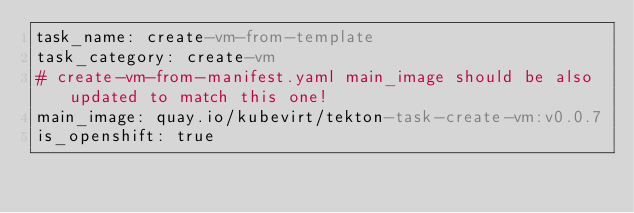Convert code to text. <code><loc_0><loc_0><loc_500><loc_500><_YAML_>task_name: create-vm-from-template
task_category: create-vm
# create-vm-from-manifest.yaml main_image should be also updated to match this one!
main_image: quay.io/kubevirt/tekton-task-create-vm:v0.0.7
is_openshift: true
</code> 